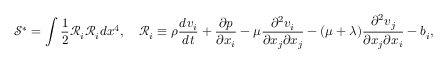Convert formula to latex. <formula><loc_0><loc_0><loc_500><loc_500>\mathcal { S } ^ { * } = \int \frac { 1 } { 2 } \mathcal { R } _ { i } \mathcal { R } _ { i } d x ^ { 4 } , \quad \mathcal { R } _ { i } \equiv \rho \frac { d v _ { i } } { d t } + \frac { \partial p } { \partial x _ { i } } - \mu \frac { \partial ^ { 2 } v _ { i } } { \partial x _ { j } \partial x _ { j } } - ( \mu + \lambda ) \frac { \partial ^ { 2 } v _ { j } } { \partial x _ { j } \partial x _ { i } } - b _ { i } ,</formula> 